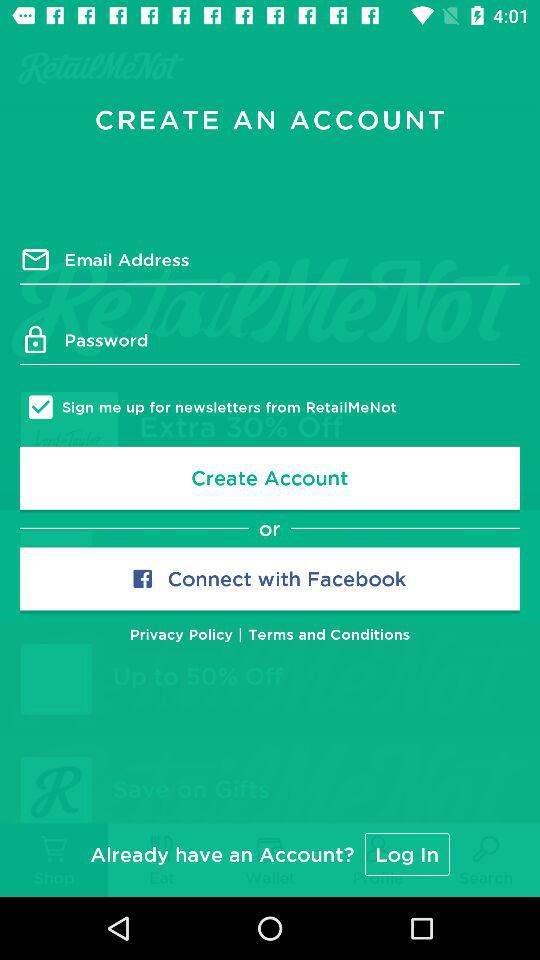How many input fields are there for creating an account?
Answer the question using a single word or phrase. 2 